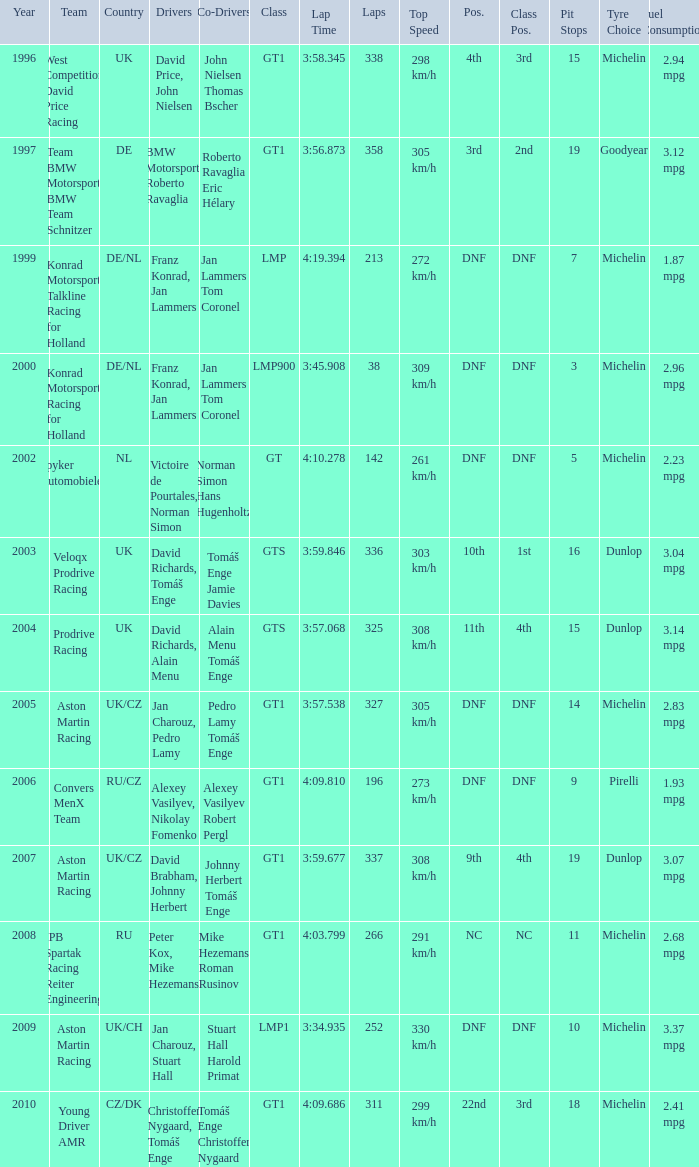What was the position in 1997? 3rd. 